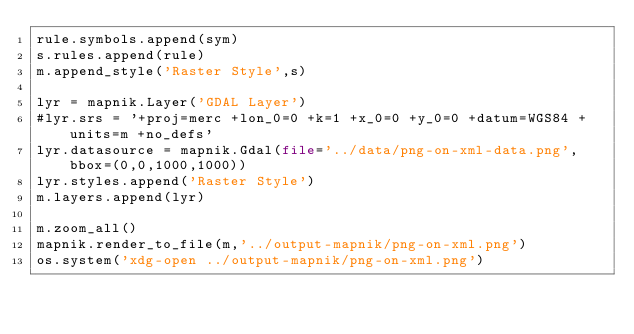Convert code to text. <code><loc_0><loc_0><loc_500><loc_500><_Python_>rule.symbols.append(sym)
s.rules.append(rule)
m.append_style('Raster Style',s)

lyr = mapnik.Layer('GDAL Layer')
#lyr.srs = '+proj=merc +lon_0=0 +k=1 +x_0=0 +y_0=0 +datum=WGS84 +units=m +no_defs'
lyr.datasource = mapnik.Gdal(file='../data/png-on-xml-data.png',bbox=(0,0,1000,1000))
lyr.styles.append('Raster Style')
m.layers.append(lyr)

m.zoom_all()
mapnik.render_to_file(m,'../output-mapnik/png-on-xml.png')
os.system('xdg-open ../output-mapnik/png-on-xml.png')</code> 